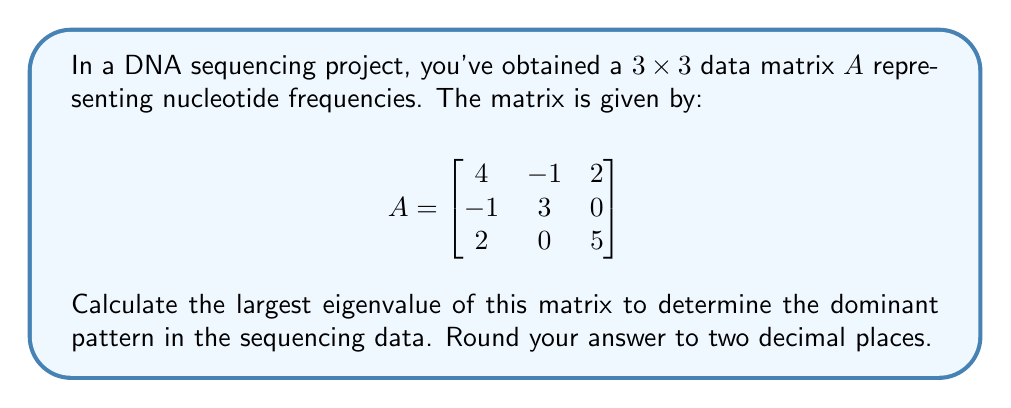Provide a solution to this math problem. To find the eigenvalues of matrix $A$, we need to solve the characteristic equation:

1) First, we set up the equation $\det(A - \lambda I) = 0$, where $I$ is the $3 \times 3$ identity matrix:

   $$\det\begin{bmatrix}
   4-\lambda & -1 & 2 \\
   -1 & 3-\lambda & 0 \\
   2 & 0 & 5-\lambda
   \end{bmatrix} = 0$$

2) Expanding the determinant:
   
   $(4-\lambda)[(3-\lambda)(5-\lambda) - 0] + (-1)[(-1)(5-\lambda) - 2(0)] + 2[(-1)(0) - (3-\lambda)(2)] = 0$

3) Simplifying:
   
   $(4-\lambda)(15-8\lambda+\lambda^2) + (-1)(-5+\lambda) + 2(-3+\lambda) = 0$

4) Expanding further:
   
   $60-32\lambda+4\lambda^2-15\lambda+8\lambda^2-\lambda^3 + 5-\lambda - 6 + 2\lambda = 0$

5) Collecting terms:
   
   $-\lambda^3 + 12\lambda^2 - 46\lambda + 59 = 0$

6) This is a cubic equation. We can solve it using the cubic formula or numerical methods. Using a calculator or computer algebra system, we find the roots (eigenvalues) are approximately:

   $\lambda_1 \approx 6.69$
   $\lambda_2 \approx 3.43$
   $\lambda_3 \approx 1.88$

7) The largest eigenvalue is $\lambda_1 \approx 6.69$, which we round to two decimal places.
Answer: 6.69 